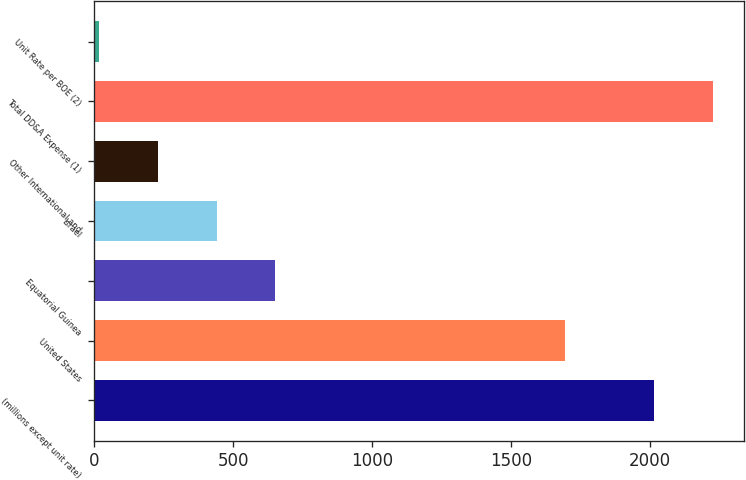Convert chart. <chart><loc_0><loc_0><loc_500><loc_500><bar_chart><fcel>(millions except unit rate)<fcel>United States<fcel>Equatorial Guinea<fcel>Israel<fcel>Other International and<fcel>Total DD&A Expense (1)<fcel>Unit Rate per BOE (2)<nl><fcel>2015<fcel>1692<fcel>651.04<fcel>439.61<fcel>228.18<fcel>2226.43<fcel>16.75<nl></chart> 